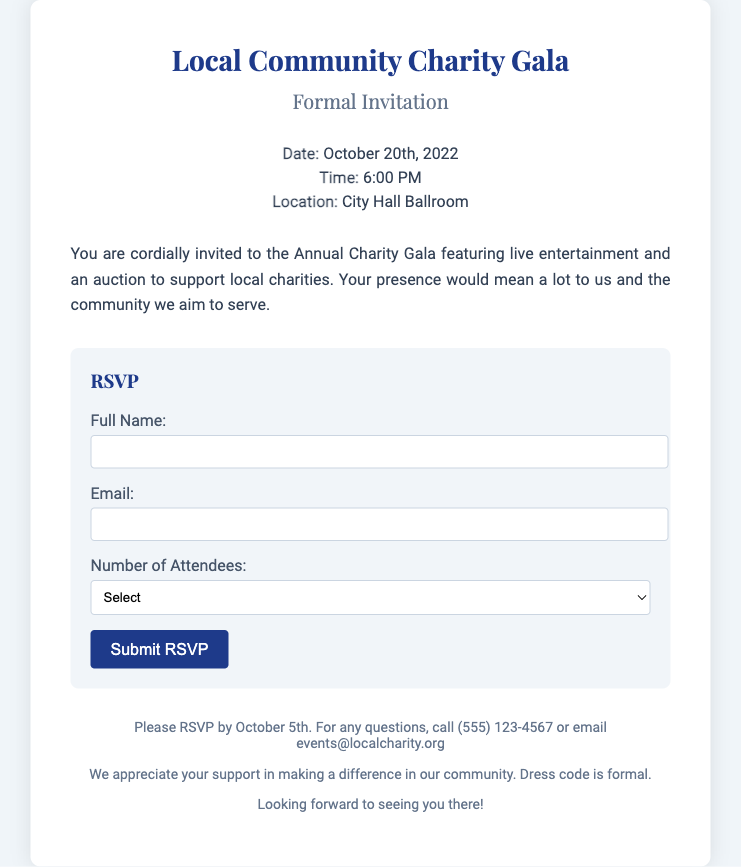What is the date of the Charity Gala? The date of the Charity Gala is stated in the details section of the document.
Answer: October 20th, 2022 What time does the event start? The start time of the event is provided clearly in the details section.
Answer: 6:00 PM Where is the event being held? The location of the event is found in the details section of the invitation.
Answer: City Hall Ballroom What is the RSVP deadline? The RSVP deadline is mentioned towards the end of the document.
Answer: October 5th How many attendees can you indicate in the RSVP? The form indicates the maximum number of attendees that can be selected.
Answer: 4 What type of entertainment will be featured at the gala? The document mentions the type of entertainment included in the event.
Answer: Live entertainment What is the dress code for the event? The dress code is specified in the footer of the document.
Answer: Formal Which organizations does the event support? The document refers to the beneficiaries of the gala in its introductory paragraph.
Answer: Local charities What should you do if you have questions regarding the event? The footer provides contact options for inquiries about the event.
Answer: Call or email 